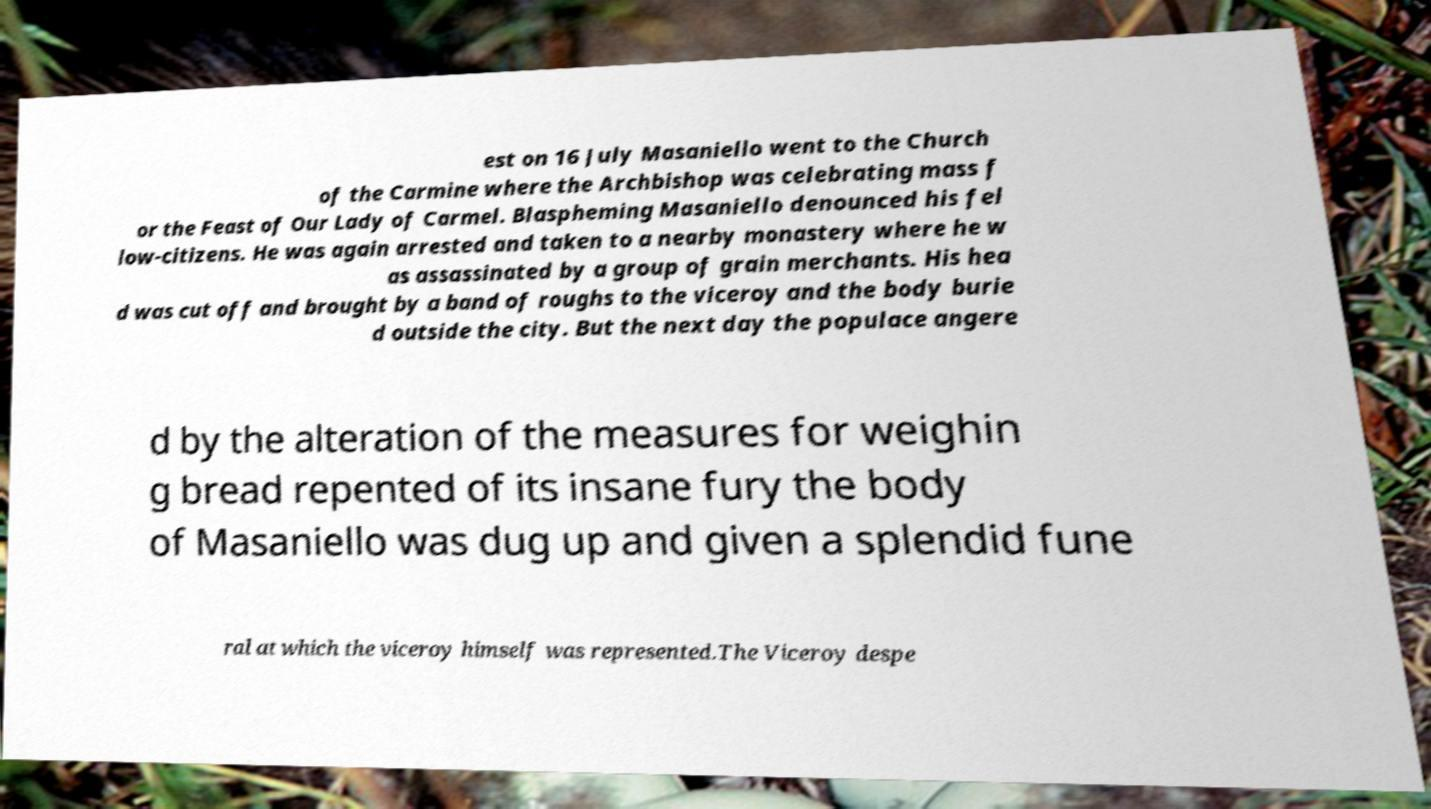Please identify and transcribe the text found in this image. est on 16 July Masaniello went to the Church of the Carmine where the Archbishop was celebrating mass f or the Feast of Our Lady of Carmel. Blaspheming Masaniello denounced his fel low-citizens. He was again arrested and taken to a nearby monastery where he w as assassinated by a group of grain merchants. His hea d was cut off and brought by a band of roughs to the viceroy and the body burie d outside the city. But the next day the populace angere d by the alteration of the measures for weighin g bread repented of its insane fury the body of Masaniello was dug up and given a splendid fune ral at which the viceroy himself was represented.The Viceroy despe 